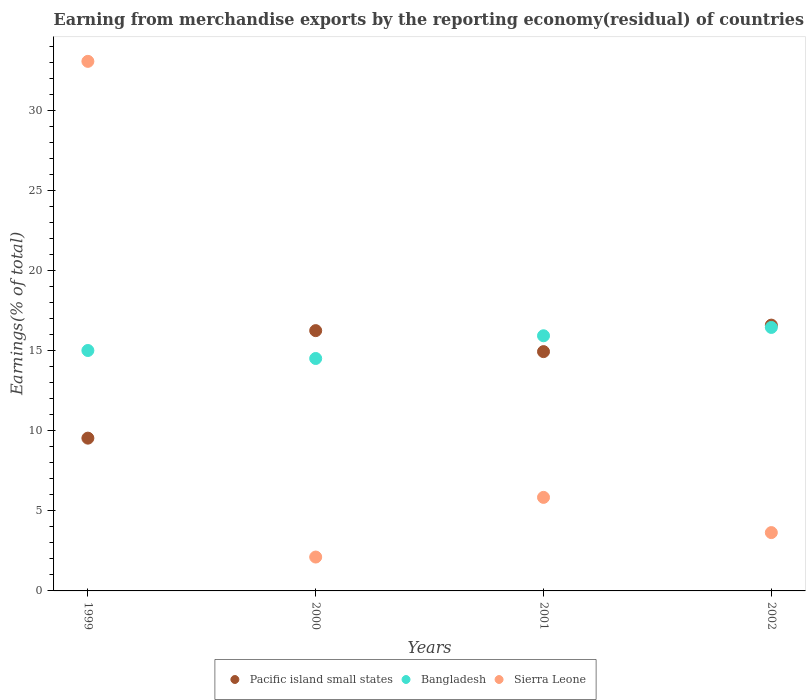Is the number of dotlines equal to the number of legend labels?
Offer a very short reply. Yes. What is the percentage of amount earned from merchandise exports in Pacific island small states in 1999?
Ensure brevity in your answer.  9.55. Across all years, what is the maximum percentage of amount earned from merchandise exports in Pacific island small states?
Ensure brevity in your answer.  16.61. Across all years, what is the minimum percentage of amount earned from merchandise exports in Sierra Leone?
Ensure brevity in your answer.  2.12. In which year was the percentage of amount earned from merchandise exports in Bangladesh maximum?
Provide a short and direct response. 2002. What is the total percentage of amount earned from merchandise exports in Pacific island small states in the graph?
Keep it short and to the point. 57.39. What is the difference between the percentage of amount earned from merchandise exports in Sierra Leone in 2000 and that in 2001?
Keep it short and to the point. -3.73. What is the difference between the percentage of amount earned from merchandise exports in Bangladesh in 2001 and the percentage of amount earned from merchandise exports in Sierra Leone in 2000?
Give a very brief answer. 13.83. What is the average percentage of amount earned from merchandise exports in Bangladesh per year?
Offer a very short reply. 15.49. In the year 2000, what is the difference between the percentage of amount earned from merchandise exports in Bangladesh and percentage of amount earned from merchandise exports in Pacific island small states?
Ensure brevity in your answer.  -1.74. What is the ratio of the percentage of amount earned from merchandise exports in Sierra Leone in 1999 to that in 2002?
Your response must be concise. 9.08. Is the difference between the percentage of amount earned from merchandise exports in Bangladesh in 1999 and 2000 greater than the difference between the percentage of amount earned from merchandise exports in Pacific island small states in 1999 and 2000?
Offer a terse response. Yes. What is the difference between the highest and the second highest percentage of amount earned from merchandise exports in Pacific island small states?
Provide a short and direct response. 0.35. What is the difference between the highest and the lowest percentage of amount earned from merchandise exports in Bangladesh?
Make the answer very short. 1.94. In how many years, is the percentage of amount earned from merchandise exports in Pacific island small states greater than the average percentage of amount earned from merchandise exports in Pacific island small states taken over all years?
Your response must be concise. 3. Does the percentage of amount earned from merchandise exports in Pacific island small states monotonically increase over the years?
Provide a succinct answer. No. Is the percentage of amount earned from merchandise exports in Bangladesh strictly greater than the percentage of amount earned from merchandise exports in Pacific island small states over the years?
Provide a succinct answer. No. Are the values on the major ticks of Y-axis written in scientific E-notation?
Keep it short and to the point. No. Does the graph contain grids?
Your answer should be very brief. No. Where does the legend appear in the graph?
Your response must be concise. Bottom center. What is the title of the graph?
Offer a terse response. Earning from merchandise exports by the reporting economy(residual) of countries. What is the label or title of the X-axis?
Your response must be concise. Years. What is the label or title of the Y-axis?
Keep it short and to the point. Earnings(% of total). What is the Earnings(% of total) in Pacific island small states in 1999?
Your answer should be very brief. 9.55. What is the Earnings(% of total) in Bangladesh in 1999?
Give a very brief answer. 15.03. What is the Earnings(% of total) of Sierra Leone in 1999?
Your response must be concise. 33.1. What is the Earnings(% of total) in Pacific island small states in 2000?
Provide a succinct answer. 16.27. What is the Earnings(% of total) in Bangladesh in 2000?
Offer a terse response. 14.53. What is the Earnings(% of total) in Sierra Leone in 2000?
Offer a very short reply. 2.12. What is the Earnings(% of total) in Pacific island small states in 2001?
Ensure brevity in your answer.  14.96. What is the Earnings(% of total) of Bangladesh in 2001?
Make the answer very short. 15.95. What is the Earnings(% of total) in Sierra Leone in 2001?
Your answer should be very brief. 5.85. What is the Earnings(% of total) in Pacific island small states in 2002?
Your response must be concise. 16.61. What is the Earnings(% of total) in Bangladesh in 2002?
Your answer should be compact. 16.47. What is the Earnings(% of total) of Sierra Leone in 2002?
Provide a short and direct response. 3.65. Across all years, what is the maximum Earnings(% of total) of Pacific island small states?
Offer a terse response. 16.61. Across all years, what is the maximum Earnings(% of total) of Bangladesh?
Offer a terse response. 16.47. Across all years, what is the maximum Earnings(% of total) of Sierra Leone?
Give a very brief answer. 33.1. Across all years, what is the minimum Earnings(% of total) of Pacific island small states?
Make the answer very short. 9.55. Across all years, what is the minimum Earnings(% of total) in Bangladesh?
Keep it short and to the point. 14.53. Across all years, what is the minimum Earnings(% of total) of Sierra Leone?
Provide a succinct answer. 2.12. What is the total Earnings(% of total) in Pacific island small states in the graph?
Your response must be concise. 57.39. What is the total Earnings(% of total) in Bangladesh in the graph?
Make the answer very short. 61.97. What is the total Earnings(% of total) of Sierra Leone in the graph?
Your answer should be compact. 44.71. What is the difference between the Earnings(% of total) in Pacific island small states in 1999 and that in 2000?
Give a very brief answer. -6.72. What is the difference between the Earnings(% of total) of Bangladesh in 1999 and that in 2000?
Your answer should be compact. 0.5. What is the difference between the Earnings(% of total) of Sierra Leone in 1999 and that in 2000?
Your answer should be very brief. 30.98. What is the difference between the Earnings(% of total) in Pacific island small states in 1999 and that in 2001?
Your answer should be compact. -5.41. What is the difference between the Earnings(% of total) in Bangladesh in 1999 and that in 2001?
Offer a very short reply. -0.92. What is the difference between the Earnings(% of total) in Sierra Leone in 1999 and that in 2001?
Offer a very short reply. 27.25. What is the difference between the Earnings(% of total) of Pacific island small states in 1999 and that in 2002?
Keep it short and to the point. -7.06. What is the difference between the Earnings(% of total) of Bangladesh in 1999 and that in 2002?
Give a very brief answer. -1.44. What is the difference between the Earnings(% of total) of Sierra Leone in 1999 and that in 2002?
Provide a succinct answer. 29.45. What is the difference between the Earnings(% of total) in Pacific island small states in 2000 and that in 2001?
Your answer should be compact. 1.31. What is the difference between the Earnings(% of total) of Bangladesh in 2000 and that in 2001?
Provide a succinct answer. -1.42. What is the difference between the Earnings(% of total) of Sierra Leone in 2000 and that in 2001?
Ensure brevity in your answer.  -3.73. What is the difference between the Earnings(% of total) of Pacific island small states in 2000 and that in 2002?
Keep it short and to the point. -0.35. What is the difference between the Earnings(% of total) of Bangladesh in 2000 and that in 2002?
Ensure brevity in your answer.  -1.94. What is the difference between the Earnings(% of total) of Sierra Leone in 2000 and that in 2002?
Your answer should be compact. -1.53. What is the difference between the Earnings(% of total) of Pacific island small states in 2001 and that in 2002?
Provide a short and direct response. -1.66. What is the difference between the Earnings(% of total) in Bangladesh in 2001 and that in 2002?
Your answer should be very brief. -0.52. What is the difference between the Earnings(% of total) in Sierra Leone in 2001 and that in 2002?
Give a very brief answer. 2.2. What is the difference between the Earnings(% of total) in Pacific island small states in 1999 and the Earnings(% of total) in Bangladesh in 2000?
Ensure brevity in your answer.  -4.98. What is the difference between the Earnings(% of total) of Pacific island small states in 1999 and the Earnings(% of total) of Sierra Leone in 2000?
Give a very brief answer. 7.43. What is the difference between the Earnings(% of total) of Bangladesh in 1999 and the Earnings(% of total) of Sierra Leone in 2000?
Your response must be concise. 12.91. What is the difference between the Earnings(% of total) in Pacific island small states in 1999 and the Earnings(% of total) in Bangladesh in 2001?
Your response must be concise. -6.4. What is the difference between the Earnings(% of total) of Pacific island small states in 1999 and the Earnings(% of total) of Sierra Leone in 2001?
Provide a succinct answer. 3.7. What is the difference between the Earnings(% of total) of Bangladesh in 1999 and the Earnings(% of total) of Sierra Leone in 2001?
Your answer should be compact. 9.18. What is the difference between the Earnings(% of total) of Pacific island small states in 1999 and the Earnings(% of total) of Bangladesh in 2002?
Your response must be concise. -6.92. What is the difference between the Earnings(% of total) of Pacific island small states in 1999 and the Earnings(% of total) of Sierra Leone in 2002?
Offer a terse response. 5.9. What is the difference between the Earnings(% of total) of Bangladesh in 1999 and the Earnings(% of total) of Sierra Leone in 2002?
Ensure brevity in your answer.  11.38. What is the difference between the Earnings(% of total) of Pacific island small states in 2000 and the Earnings(% of total) of Bangladesh in 2001?
Keep it short and to the point. 0.32. What is the difference between the Earnings(% of total) of Pacific island small states in 2000 and the Earnings(% of total) of Sierra Leone in 2001?
Give a very brief answer. 10.42. What is the difference between the Earnings(% of total) in Bangladesh in 2000 and the Earnings(% of total) in Sierra Leone in 2001?
Provide a short and direct response. 8.68. What is the difference between the Earnings(% of total) of Pacific island small states in 2000 and the Earnings(% of total) of Sierra Leone in 2002?
Your answer should be very brief. 12.62. What is the difference between the Earnings(% of total) in Bangladesh in 2000 and the Earnings(% of total) in Sierra Leone in 2002?
Offer a terse response. 10.88. What is the difference between the Earnings(% of total) in Pacific island small states in 2001 and the Earnings(% of total) in Bangladesh in 2002?
Keep it short and to the point. -1.51. What is the difference between the Earnings(% of total) of Pacific island small states in 2001 and the Earnings(% of total) of Sierra Leone in 2002?
Offer a terse response. 11.31. What is the difference between the Earnings(% of total) of Bangladesh in 2001 and the Earnings(% of total) of Sierra Leone in 2002?
Provide a succinct answer. 12.3. What is the average Earnings(% of total) in Pacific island small states per year?
Your answer should be compact. 14.35. What is the average Earnings(% of total) of Bangladesh per year?
Keep it short and to the point. 15.49. What is the average Earnings(% of total) in Sierra Leone per year?
Give a very brief answer. 11.18. In the year 1999, what is the difference between the Earnings(% of total) in Pacific island small states and Earnings(% of total) in Bangladesh?
Ensure brevity in your answer.  -5.48. In the year 1999, what is the difference between the Earnings(% of total) of Pacific island small states and Earnings(% of total) of Sierra Leone?
Provide a short and direct response. -23.55. In the year 1999, what is the difference between the Earnings(% of total) in Bangladesh and Earnings(% of total) in Sierra Leone?
Your answer should be compact. -18.07. In the year 2000, what is the difference between the Earnings(% of total) in Pacific island small states and Earnings(% of total) in Bangladesh?
Provide a succinct answer. 1.74. In the year 2000, what is the difference between the Earnings(% of total) in Pacific island small states and Earnings(% of total) in Sierra Leone?
Make the answer very short. 14.15. In the year 2000, what is the difference between the Earnings(% of total) in Bangladesh and Earnings(% of total) in Sierra Leone?
Give a very brief answer. 12.41. In the year 2001, what is the difference between the Earnings(% of total) of Pacific island small states and Earnings(% of total) of Bangladesh?
Make the answer very short. -0.99. In the year 2001, what is the difference between the Earnings(% of total) of Pacific island small states and Earnings(% of total) of Sierra Leone?
Make the answer very short. 9.11. In the year 2001, what is the difference between the Earnings(% of total) of Bangladesh and Earnings(% of total) of Sierra Leone?
Keep it short and to the point. 10.1. In the year 2002, what is the difference between the Earnings(% of total) of Pacific island small states and Earnings(% of total) of Bangladesh?
Ensure brevity in your answer.  0.14. In the year 2002, what is the difference between the Earnings(% of total) of Pacific island small states and Earnings(% of total) of Sierra Leone?
Make the answer very short. 12.97. In the year 2002, what is the difference between the Earnings(% of total) in Bangladesh and Earnings(% of total) in Sierra Leone?
Keep it short and to the point. 12.82. What is the ratio of the Earnings(% of total) of Pacific island small states in 1999 to that in 2000?
Offer a very short reply. 0.59. What is the ratio of the Earnings(% of total) of Bangladesh in 1999 to that in 2000?
Ensure brevity in your answer.  1.03. What is the ratio of the Earnings(% of total) of Sierra Leone in 1999 to that in 2000?
Your answer should be very brief. 15.63. What is the ratio of the Earnings(% of total) in Pacific island small states in 1999 to that in 2001?
Offer a very short reply. 0.64. What is the ratio of the Earnings(% of total) in Bangladesh in 1999 to that in 2001?
Your answer should be compact. 0.94. What is the ratio of the Earnings(% of total) in Sierra Leone in 1999 to that in 2001?
Your answer should be compact. 5.66. What is the ratio of the Earnings(% of total) in Pacific island small states in 1999 to that in 2002?
Provide a short and direct response. 0.57. What is the ratio of the Earnings(% of total) in Bangladesh in 1999 to that in 2002?
Give a very brief answer. 0.91. What is the ratio of the Earnings(% of total) in Sierra Leone in 1999 to that in 2002?
Your answer should be very brief. 9.08. What is the ratio of the Earnings(% of total) of Pacific island small states in 2000 to that in 2001?
Keep it short and to the point. 1.09. What is the ratio of the Earnings(% of total) in Bangladesh in 2000 to that in 2001?
Make the answer very short. 0.91. What is the ratio of the Earnings(% of total) of Sierra Leone in 2000 to that in 2001?
Provide a succinct answer. 0.36. What is the ratio of the Earnings(% of total) of Pacific island small states in 2000 to that in 2002?
Your answer should be compact. 0.98. What is the ratio of the Earnings(% of total) of Bangladesh in 2000 to that in 2002?
Give a very brief answer. 0.88. What is the ratio of the Earnings(% of total) in Sierra Leone in 2000 to that in 2002?
Your answer should be compact. 0.58. What is the ratio of the Earnings(% of total) in Pacific island small states in 2001 to that in 2002?
Ensure brevity in your answer.  0.9. What is the ratio of the Earnings(% of total) in Bangladesh in 2001 to that in 2002?
Your answer should be compact. 0.97. What is the ratio of the Earnings(% of total) in Sierra Leone in 2001 to that in 2002?
Offer a terse response. 1.6. What is the difference between the highest and the second highest Earnings(% of total) in Pacific island small states?
Provide a succinct answer. 0.35. What is the difference between the highest and the second highest Earnings(% of total) of Bangladesh?
Keep it short and to the point. 0.52. What is the difference between the highest and the second highest Earnings(% of total) of Sierra Leone?
Ensure brevity in your answer.  27.25. What is the difference between the highest and the lowest Earnings(% of total) in Pacific island small states?
Offer a very short reply. 7.06. What is the difference between the highest and the lowest Earnings(% of total) in Bangladesh?
Provide a succinct answer. 1.94. What is the difference between the highest and the lowest Earnings(% of total) in Sierra Leone?
Your answer should be compact. 30.98. 